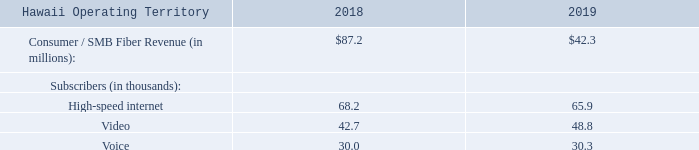During the year, we passed an additional 12,400 addresses in the Greater Cincinnati area with Fioptics, which included a focus on Fiber to the Premise ("FTTP") addresses as FTTP has become a more relevant solution for our customers. As of December 31, 2019, the Fioptics products are now available to approximately 623,400 customer locations or 75% of the Greater Cincinnati operating territory. During 2019, we passed an additional 5,900 addresses in Hawaii.  The Consumer/SMB Fiber products are now available to approximately 246,400 addresses, or 50% of the operating territory in Hawaii, including Oahu and the neighbor islands
In 2019, the Company also invested $24.0 million in Enterprise Fiber products, which includes fiber and IP-ased core network technology.  These investments position the Company to meet increased business and carrier demand within Greater Cincinnati and in contiguous markets in the Midwest region.  In Hawaii, expenditures are for high-bandwidth data transport products, such as metro-ethernet, including the Southeast Asia to United States ("SEA-US") cable.  We continue to evolve and optimize network assets to support the migration of legacy products to new technology, and as of December 31, 2019, the Company has:
increased the total number of commercial addresses with fiber-based services (referred to as a lit address) to 28,800 in Greater Cincinnati and 20,300 in Hawaii by connecting approximately 2,200 additional lit addresses in Greater Cincinnati and 1,200 additional lit addresses in Hawaii during the twelve months ended December 31, 2019;
expanded the fiber network to span more than 12,500 route miles in Greater Cincinnati and 4,700 route miles in Hawaii; and
provided cell site back-haul services to approximately 90% of the 1,000 cell sites in the Greater Cincinnati market, of which approximately 97% of these sites are lit with fiber, and 80% of the 1,100 cell sites in Hawaii, all of which are lit with fiber.
As a result of our investments, we have generated year-over-year Entertainment and Communications revenue growth each year since 2013.  The Company's expanding fiber assets allow us to support the ever-increasing demand for data, video and internet devices with speed, agility and security.  We believe our fiber investments are a long-term solution for our customers' bandwidth needs
What proportion of the amount invested in Enterprise Fiber products is the 2019 revenue?
Answer scale should be: percent. 87.2/24
Answer: 363.33. What is the total number of subscribers in 2019?
Answer scale should be: thousand. 68.2+42.7+30.0
Answer: 140.9. What is the percentage change in Hiah-speed internet Subscribers between 2018 to 2019?
Answer scale should be: percent. (68.2-65.9)/65.9
Answer: 3.49. What is the total revenue earned across 2018 to 2019?
Answer scale should be: million. 87.2+42.3
Answer: 129.5. When did the company start enjoying year on year  Entertainment and Communications revenue growth? 2013. What is the fiber network expansion in Hawaii? 4,700. How many video subscribers are there in 2018?
Answer scale should be: thousand. 48.8. 